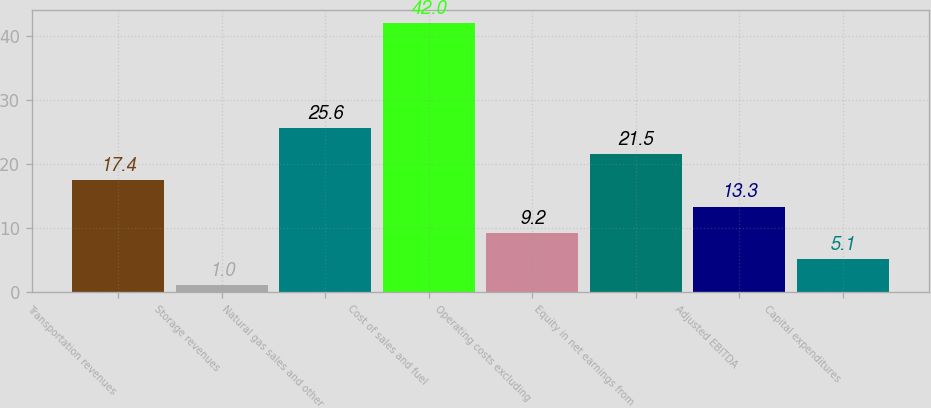<chart> <loc_0><loc_0><loc_500><loc_500><bar_chart><fcel>Transportation revenues<fcel>Storage revenues<fcel>Natural gas sales and other<fcel>Cost of sales and fuel<fcel>Operating costs excluding<fcel>Equity in net earnings from<fcel>Adjusted EBITDA<fcel>Capital expenditures<nl><fcel>17.4<fcel>1<fcel>25.6<fcel>42<fcel>9.2<fcel>21.5<fcel>13.3<fcel>5.1<nl></chart> 